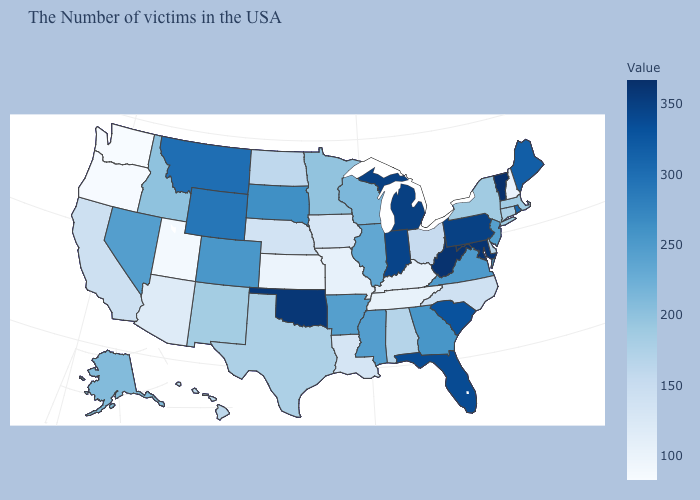Which states have the lowest value in the USA?
Write a very short answer. Washington. Among the states that border Nevada , which have the lowest value?
Keep it brief. Oregon. Which states have the highest value in the USA?
Give a very brief answer. Vermont. Is the legend a continuous bar?
Keep it brief. Yes. Among the states that border Maryland , does Virginia have the highest value?
Keep it brief. No. Does Idaho have a lower value than South Dakota?
Short answer required. Yes. Which states have the lowest value in the Northeast?
Answer briefly. New Hampshire. 